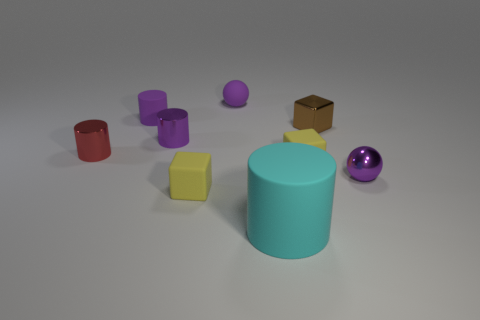There is another tiny sphere that is the same color as the small metal ball; what material is it?
Provide a succinct answer. Rubber. How many small purple matte spheres are there?
Give a very brief answer. 1. Are there any purple objects that have the same material as the brown block?
Offer a terse response. Yes. Does the purple ball right of the big cyan object have the same size as the rubber cylinder on the right side of the tiny purple matte sphere?
Provide a succinct answer. No. What size is the purple ball that is left of the brown metallic block?
Your response must be concise. Small. Are there any small rubber cylinders of the same color as the rubber sphere?
Provide a short and direct response. Yes. There is a ball that is in front of the small purple matte cylinder; is there a big cyan cylinder on the right side of it?
Offer a very short reply. No. There is a red metal cylinder; is it the same size as the matte cube that is behind the small metallic sphere?
Give a very brief answer. Yes. There is a tiny thing that is to the left of the rubber cylinder behind the brown block; are there any small objects that are behind it?
Give a very brief answer. Yes. There is a purple sphere that is left of the brown cube; what is its material?
Make the answer very short. Rubber. 